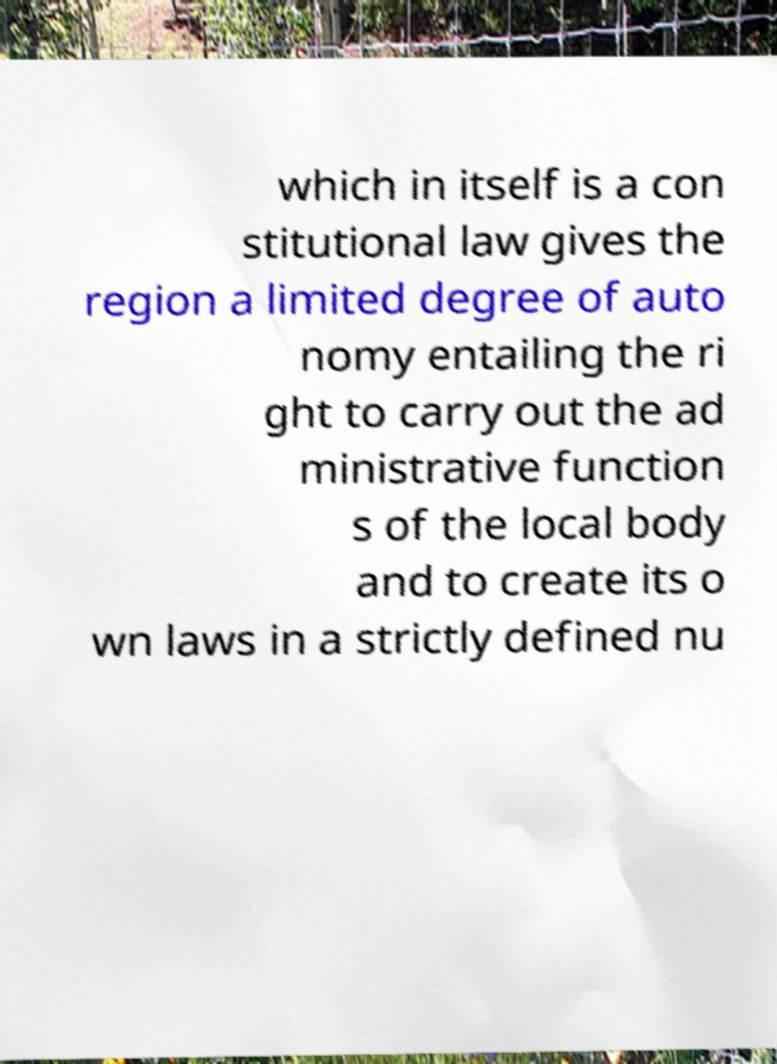I need the written content from this picture converted into text. Can you do that? which in itself is a con stitutional law gives the region a limited degree of auto nomy entailing the ri ght to carry out the ad ministrative function s of the local body and to create its o wn laws in a strictly defined nu 